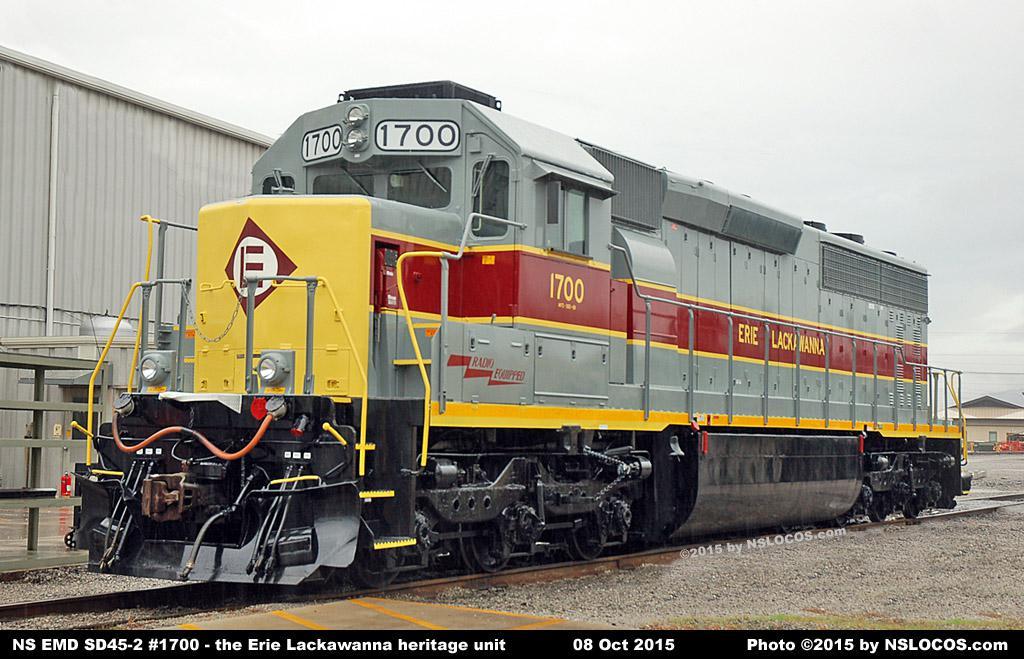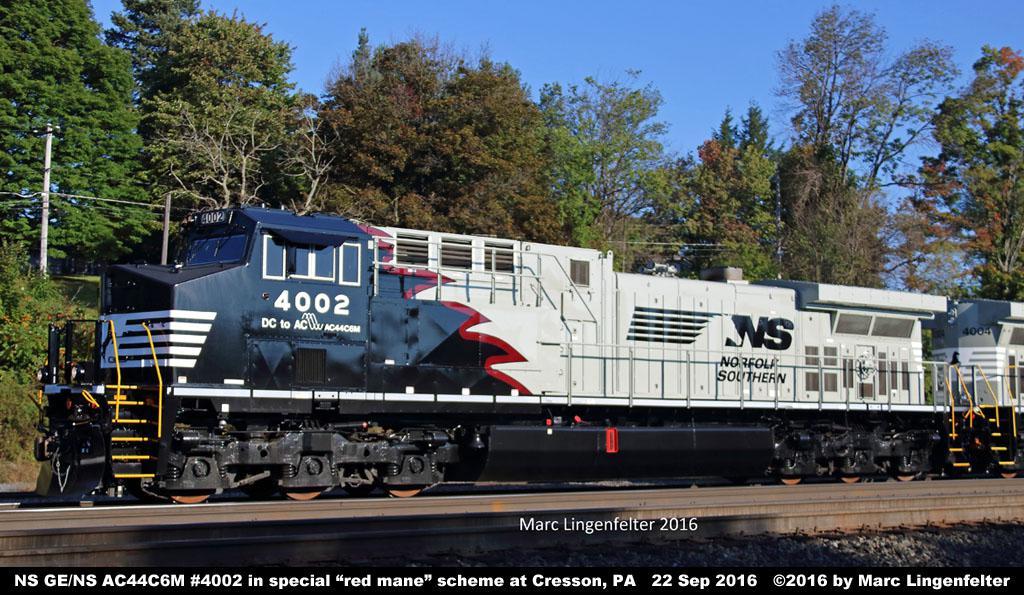The first image is the image on the left, the second image is the image on the right. Given the left and right images, does the statement "A train has a bright yellow front and faces leftward." hold true? Answer yes or no. Yes. The first image is the image on the left, the second image is the image on the right. For the images displayed, is the sentence "The left image contains a train that is headed towards the right." factually correct? Answer yes or no. No. 